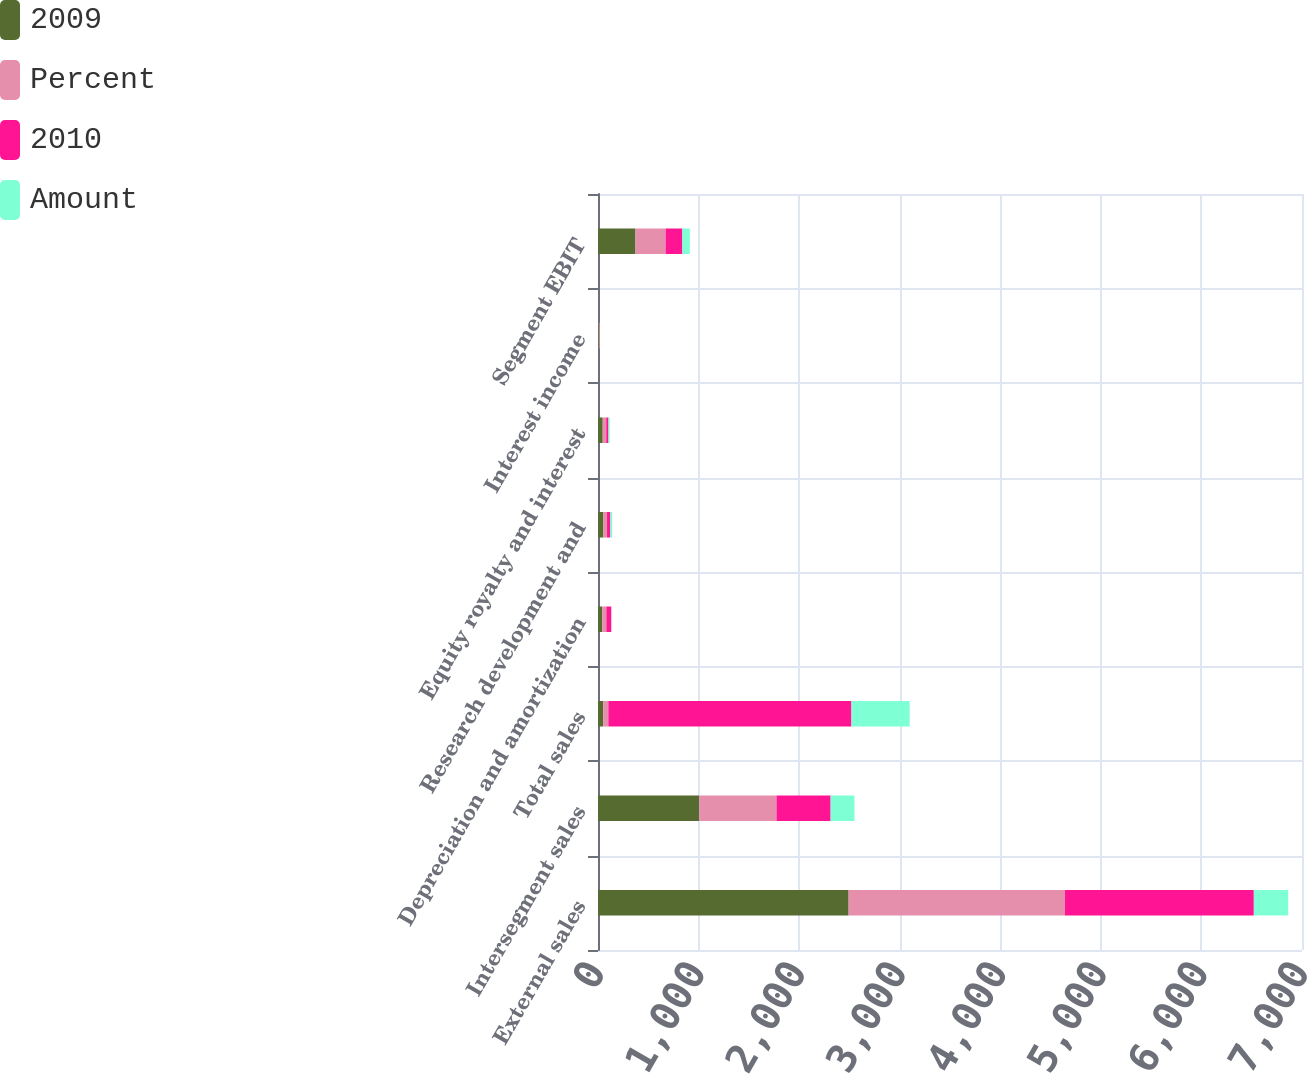Convert chart to OTSL. <chart><loc_0><loc_0><loc_500><loc_500><stacked_bar_chart><ecel><fcel>External sales<fcel>Intersegment sales<fcel>Total sales<fcel>Depreciation and amortization<fcel>Research development and<fcel>Equity royalty and interest<fcel>Interest income<fcel>Segment EBIT<nl><fcel>2009<fcel>2492<fcel>1006<fcel>51.5<fcel>42<fcel>54<fcel>47<fcel>8<fcel>373<nl><fcel>Percent<fcel>2150<fcel>769<fcel>51.5<fcel>41<fcel>36<fcel>35<fcel>5<fcel>299<nl><fcel>2010<fcel>1879<fcel>538<fcel>2417<fcel>49<fcel>33<fcel>22<fcel>3<fcel>167<nl><fcel>Amount<fcel>342<fcel>237<fcel>579<fcel>1<fcel>18<fcel>12<fcel>3<fcel>74<nl></chart> 